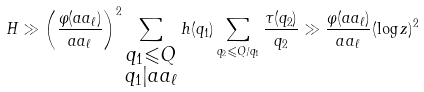Convert formula to latex. <formula><loc_0><loc_0><loc_500><loc_500>H \gg \left ( \frac { \varphi ( a a _ { \ell } ) } { a a _ { \ell } } \right ) ^ { 2 } \sum _ { \substack { q _ { 1 } \leqslant Q \\ q _ { 1 } | a a _ { \ell } } } h ( q _ { 1 } ) \sum _ { q _ { 2 } \leqslant Q / q _ { 1 } } \frac { \tau ( q _ { 2 } ) } { q _ { 2 } } \gg \frac { \varphi ( a a _ { \ell } ) } { a a _ { \ell } } ( \log z ) ^ { 2 }</formula> 